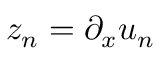Convert formula to latex. <formula><loc_0><loc_0><loc_500><loc_500>z _ { n } = \partial _ { x } u _ { n }</formula> 